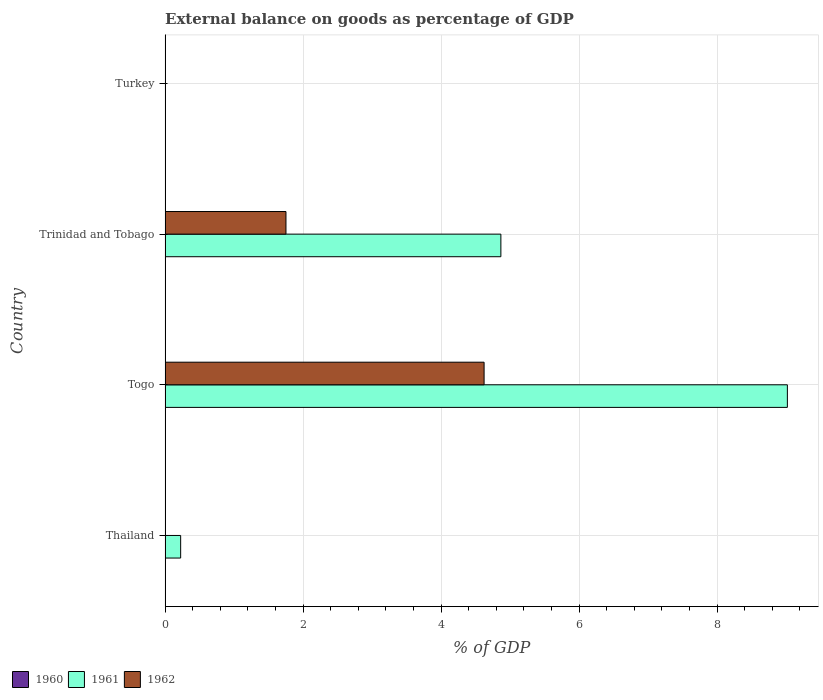Are the number of bars per tick equal to the number of legend labels?
Keep it short and to the point. No. Are the number of bars on each tick of the Y-axis equal?
Offer a terse response. No. How many bars are there on the 2nd tick from the top?
Offer a terse response. 2. How many bars are there on the 1st tick from the bottom?
Your response must be concise. 1. What is the label of the 1st group of bars from the top?
Provide a succinct answer. Turkey. What is the external balance on goods as percentage of GDP in 1962 in Trinidad and Tobago?
Ensure brevity in your answer.  1.75. Across all countries, what is the maximum external balance on goods as percentage of GDP in 1961?
Make the answer very short. 9.02. Across all countries, what is the minimum external balance on goods as percentage of GDP in 1961?
Ensure brevity in your answer.  0. In which country was the external balance on goods as percentage of GDP in 1962 maximum?
Offer a very short reply. Togo. What is the total external balance on goods as percentage of GDP in 1961 in the graph?
Offer a terse response. 14.11. What is the difference between the external balance on goods as percentage of GDP in 1961 in Thailand and that in Trinidad and Tobago?
Offer a very short reply. -4.64. What is the difference between the external balance on goods as percentage of GDP in 1960 in Trinidad and Tobago and the external balance on goods as percentage of GDP in 1961 in Turkey?
Provide a succinct answer. 0. What is the average external balance on goods as percentage of GDP in 1962 per country?
Offer a terse response. 1.59. What is the difference between the external balance on goods as percentage of GDP in 1961 and external balance on goods as percentage of GDP in 1962 in Togo?
Provide a short and direct response. 4.4. In how many countries, is the external balance on goods as percentage of GDP in 1960 greater than 3.6 %?
Provide a short and direct response. 0. What is the ratio of the external balance on goods as percentage of GDP in 1961 in Thailand to that in Togo?
Make the answer very short. 0.02. Is the external balance on goods as percentage of GDP in 1961 in Thailand less than that in Trinidad and Tobago?
Keep it short and to the point. Yes. Is the difference between the external balance on goods as percentage of GDP in 1961 in Togo and Trinidad and Tobago greater than the difference between the external balance on goods as percentage of GDP in 1962 in Togo and Trinidad and Tobago?
Keep it short and to the point. Yes. What is the difference between the highest and the second highest external balance on goods as percentage of GDP in 1961?
Offer a very short reply. 4.15. What is the difference between the highest and the lowest external balance on goods as percentage of GDP in 1962?
Ensure brevity in your answer.  4.62. Is it the case that in every country, the sum of the external balance on goods as percentage of GDP in 1960 and external balance on goods as percentage of GDP in 1961 is greater than the external balance on goods as percentage of GDP in 1962?
Your answer should be very brief. No. How many bars are there?
Offer a terse response. 5. How many countries are there in the graph?
Keep it short and to the point. 4. Does the graph contain grids?
Your answer should be compact. Yes. How are the legend labels stacked?
Give a very brief answer. Horizontal. What is the title of the graph?
Your answer should be very brief. External balance on goods as percentage of GDP. What is the label or title of the X-axis?
Give a very brief answer. % of GDP. What is the % of GDP in 1960 in Thailand?
Your answer should be compact. 0. What is the % of GDP of 1961 in Thailand?
Ensure brevity in your answer.  0.23. What is the % of GDP in 1961 in Togo?
Offer a terse response. 9.02. What is the % of GDP in 1962 in Togo?
Your response must be concise. 4.62. What is the % of GDP in 1961 in Trinidad and Tobago?
Make the answer very short. 4.87. What is the % of GDP of 1962 in Trinidad and Tobago?
Provide a succinct answer. 1.75. Across all countries, what is the maximum % of GDP of 1961?
Ensure brevity in your answer.  9.02. Across all countries, what is the maximum % of GDP of 1962?
Keep it short and to the point. 4.62. Across all countries, what is the minimum % of GDP in 1962?
Provide a succinct answer. 0. What is the total % of GDP of 1961 in the graph?
Your response must be concise. 14.11. What is the total % of GDP of 1962 in the graph?
Provide a succinct answer. 6.37. What is the difference between the % of GDP of 1961 in Thailand and that in Togo?
Make the answer very short. -8.79. What is the difference between the % of GDP in 1961 in Thailand and that in Trinidad and Tobago?
Provide a succinct answer. -4.64. What is the difference between the % of GDP in 1961 in Togo and that in Trinidad and Tobago?
Your response must be concise. 4.15. What is the difference between the % of GDP of 1962 in Togo and that in Trinidad and Tobago?
Provide a short and direct response. 2.87. What is the difference between the % of GDP of 1961 in Thailand and the % of GDP of 1962 in Togo?
Give a very brief answer. -4.4. What is the difference between the % of GDP of 1961 in Thailand and the % of GDP of 1962 in Trinidad and Tobago?
Your answer should be compact. -1.53. What is the difference between the % of GDP in 1961 in Togo and the % of GDP in 1962 in Trinidad and Tobago?
Your response must be concise. 7.27. What is the average % of GDP of 1961 per country?
Ensure brevity in your answer.  3.53. What is the average % of GDP of 1962 per country?
Give a very brief answer. 1.59. What is the difference between the % of GDP of 1961 and % of GDP of 1962 in Togo?
Provide a succinct answer. 4.4. What is the difference between the % of GDP in 1961 and % of GDP in 1962 in Trinidad and Tobago?
Your answer should be very brief. 3.11. What is the ratio of the % of GDP of 1961 in Thailand to that in Togo?
Offer a terse response. 0.03. What is the ratio of the % of GDP in 1961 in Thailand to that in Trinidad and Tobago?
Keep it short and to the point. 0.05. What is the ratio of the % of GDP in 1961 in Togo to that in Trinidad and Tobago?
Keep it short and to the point. 1.85. What is the ratio of the % of GDP in 1962 in Togo to that in Trinidad and Tobago?
Your response must be concise. 2.64. What is the difference between the highest and the second highest % of GDP in 1961?
Keep it short and to the point. 4.15. What is the difference between the highest and the lowest % of GDP in 1961?
Offer a very short reply. 9.02. What is the difference between the highest and the lowest % of GDP of 1962?
Give a very brief answer. 4.62. 